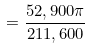<formula> <loc_0><loc_0><loc_500><loc_500>= \frac { 5 2 , 9 0 0 \pi } { 2 1 1 , 6 0 0 }</formula> 